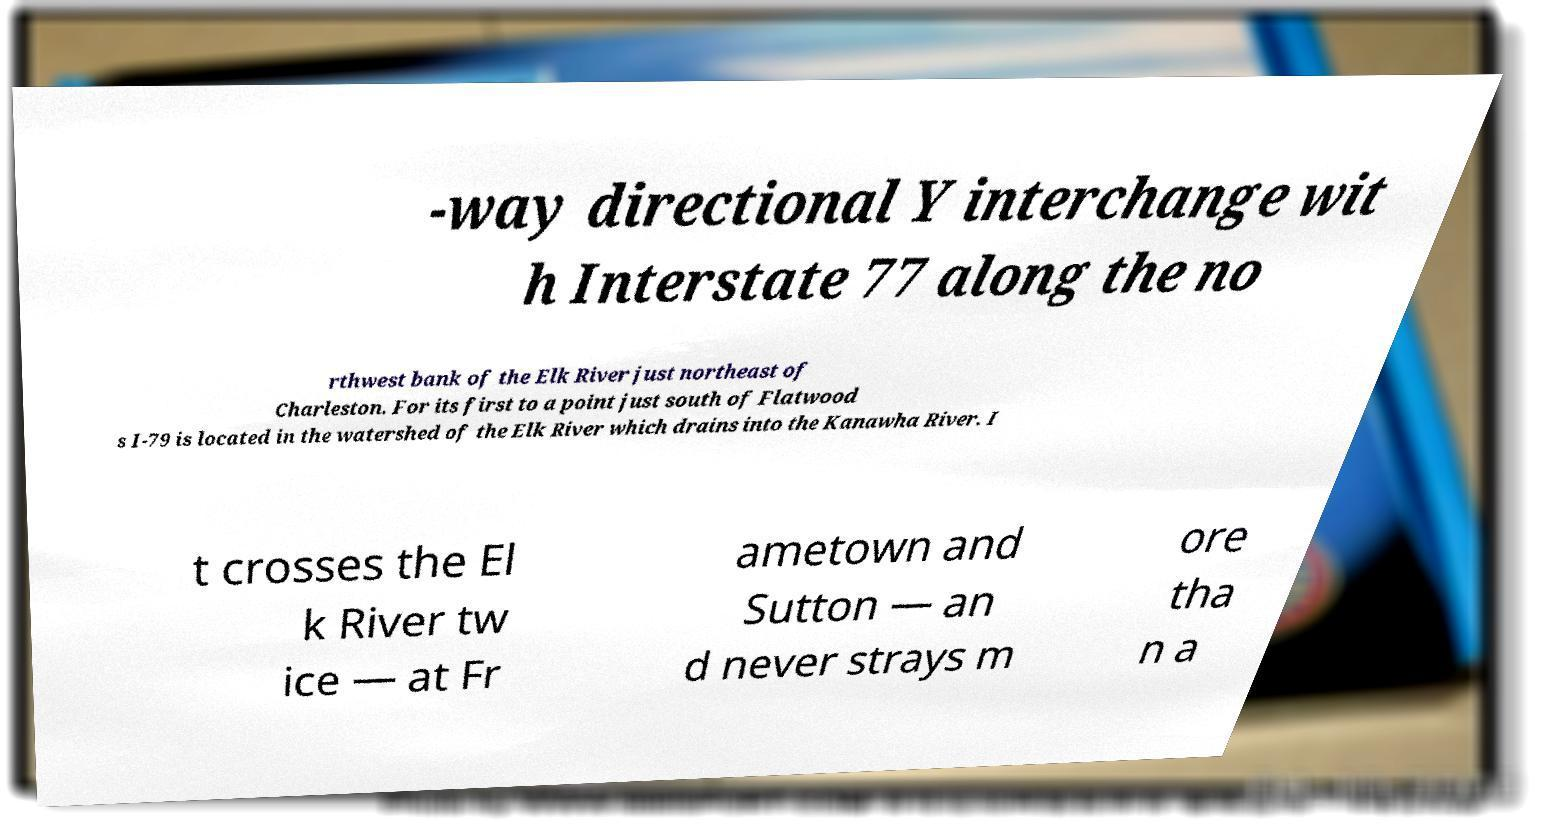Please read and relay the text visible in this image. What does it say? -way directional Y interchange wit h Interstate 77 along the no rthwest bank of the Elk River just northeast of Charleston. For its first to a point just south of Flatwood s I-79 is located in the watershed of the Elk River which drains into the Kanawha River. I t crosses the El k River tw ice — at Fr ametown and Sutton — an d never strays m ore tha n a 